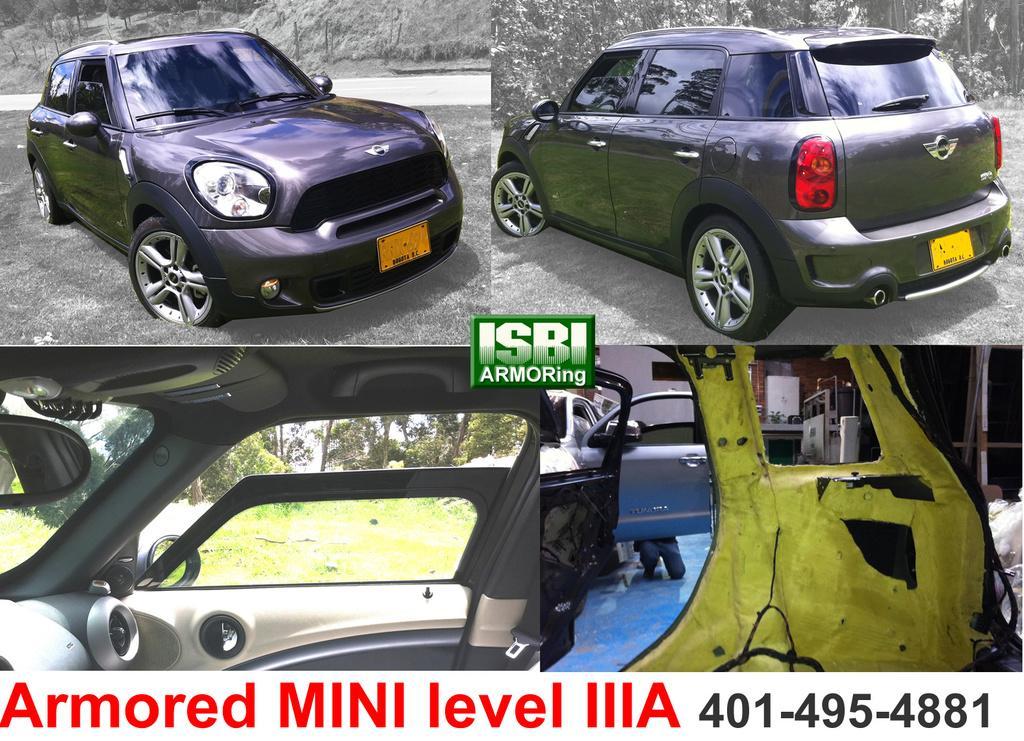Please provide a concise description of this image. This is a collage picture. I can see vehicles, trees and some other objects, and in the background there is the sky and there are watermarks on the image. 